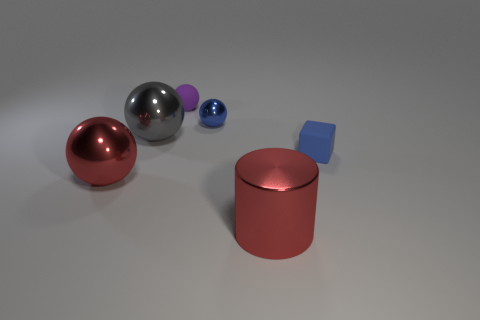The sphere that is the same color as the large metallic cylinder is what size?
Offer a terse response. Large. Is there a ball behind the tiny blue thing that is behind the gray shiny ball that is on the left side of the tiny blue matte block?
Offer a terse response. Yes. The blue block is what size?
Your answer should be compact. Small. What number of cylinders have the same size as the purple matte object?
Offer a very short reply. 0. There is another purple object that is the same shape as the tiny metal thing; what is it made of?
Ensure brevity in your answer.  Rubber. The object that is both left of the small shiny sphere and behind the large gray object has what shape?
Give a very brief answer. Sphere. What is the shape of the small rubber object that is behind the small blue matte object?
Provide a short and direct response. Sphere. How many balls are both left of the big gray sphere and behind the gray shiny object?
Provide a short and direct response. 0. Does the cylinder have the same size as the matte thing on the right side of the purple ball?
Provide a succinct answer. No. What size is the matte thing to the left of the matte thing to the right of the small purple matte ball that is behind the gray sphere?
Give a very brief answer. Small. 